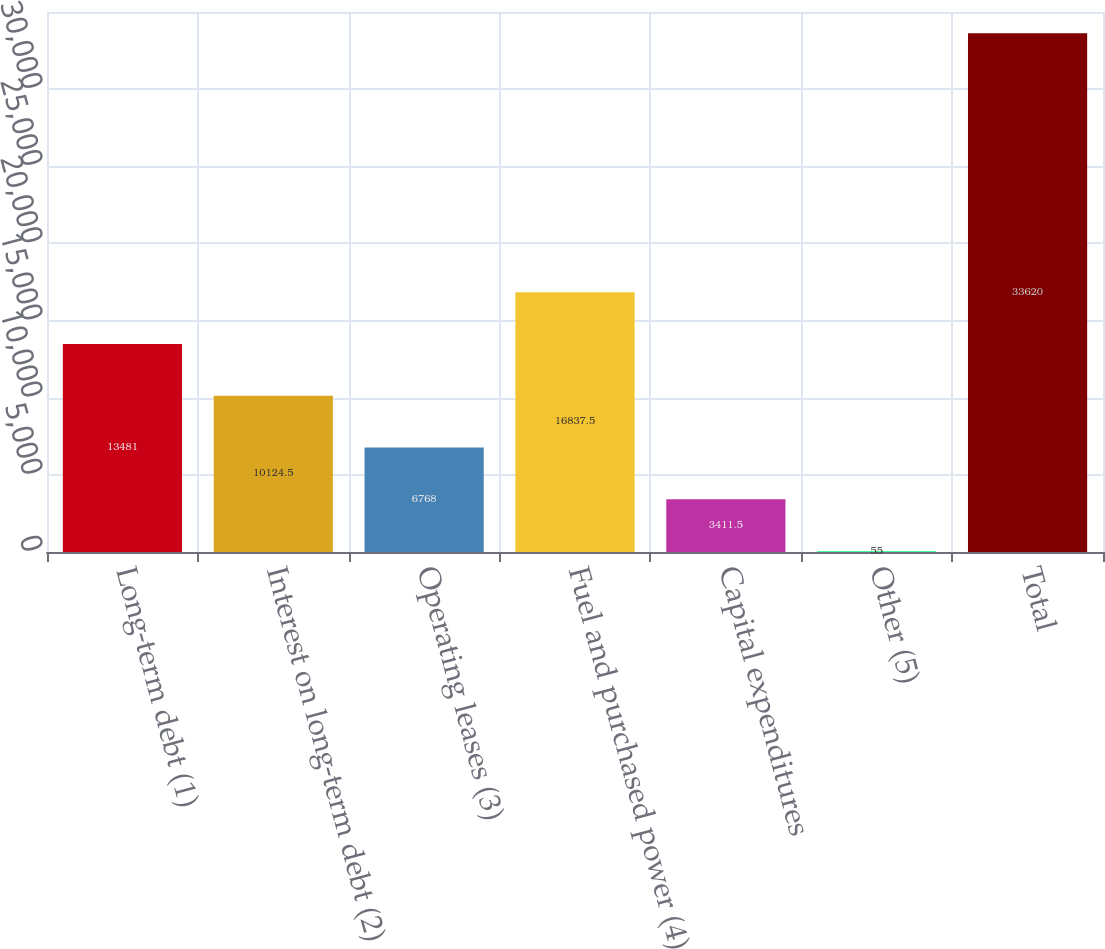Convert chart. <chart><loc_0><loc_0><loc_500><loc_500><bar_chart><fcel>Long-term debt (1)<fcel>Interest on long-term debt (2)<fcel>Operating leases (3)<fcel>Fuel and purchased power (4)<fcel>Capital expenditures<fcel>Other (5)<fcel>Total<nl><fcel>13481<fcel>10124.5<fcel>6768<fcel>16837.5<fcel>3411.5<fcel>55<fcel>33620<nl></chart> 